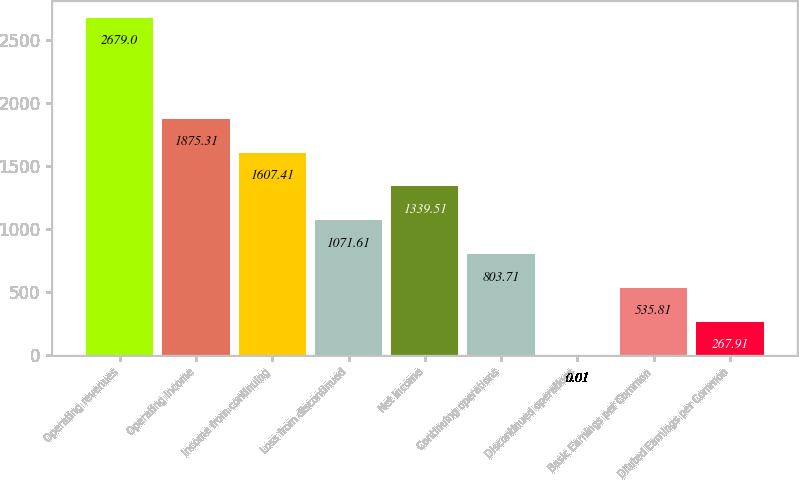Convert chart to OTSL. <chart><loc_0><loc_0><loc_500><loc_500><bar_chart><fcel>Operating revenues<fcel>Operating income<fcel>Income from continuing<fcel>Loss from discontinued<fcel>Net income<fcel>Continuing operations<fcel>Discontinued operations<fcel>Basic Earnings per Common<fcel>Diluted Earnings per Common<nl><fcel>2679<fcel>1875.31<fcel>1607.41<fcel>1071.61<fcel>1339.51<fcel>803.71<fcel>0.01<fcel>535.81<fcel>267.91<nl></chart> 